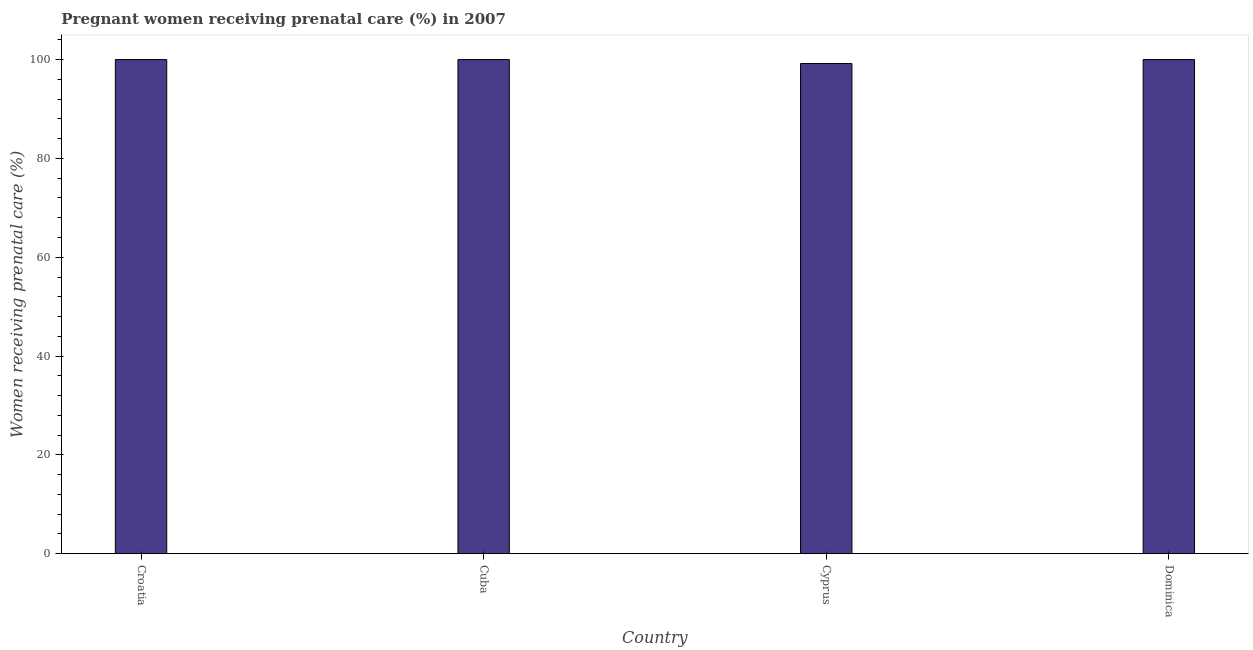Does the graph contain any zero values?
Offer a very short reply. No. What is the title of the graph?
Provide a succinct answer. Pregnant women receiving prenatal care (%) in 2007. What is the label or title of the Y-axis?
Offer a very short reply. Women receiving prenatal care (%). What is the percentage of pregnant women receiving prenatal care in Cyprus?
Your answer should be compact. 99.2. Across all countries, what is the minimum percentage of pregnant women receiving prenatal care?
Make the answer very short. 99.2. In which country was the percentage of pregnant women receiving prenatal care maximum?
Provide a short and direct response. Croatia. In which country was the percentage of pregnant women receiving prenatal care minimum?
Give a very brief answer. Cyprus. What is the sum of the percentage of pregnant women receiving prenatal care?
Your response must be concise. 399.2. What is the average percentage of pregnant women receiving prenatal care per country?
Provide a succinct answer. 99.8. What is the median percentage of pregnant women receiving prenatal care?
Offer a terse response. 100. Is the sum of the percentage of pregnant women receiving prenatal care in Cuba and Dominica greater than the maximum percentage of pregnant women receiving prenatal care across all countries?
Keep it short and to the point. Yes. What is the difference between the highest and the lowest percentage of pregnant women receiving prenatal care?
Offer a very short reply. 0.8. In how many countries, is the percentage of pregnant women receiving prenatal care greater than the average percentage of pregnant women receiving prenatal care taken over all countries?
Ensure brevity in your answer.  3. How many bars are there?
Provide a succinct answer. 4. Are all the bars in the graph horizontal?
Give a very brief answer. No. How many countries are there in the graph?
Make the answer very short. 4. Are the values on the major ticks of Y-axis written in scientific E-notation?
Your answer should be compact. No. What is the Women receiving prenatal care (%) of Croatia?
Provide a short and direct response. 100. What is the Women receiving prenatal care (%) of Cuba?
Provide a succinct answer. 100. What is the Women receiving prenatal care (%) of Cyprus?
Make the answer very short. 99.2. What is the Women receiving prenatal care (%) in Dominica?
Give a very brief answer. 100. What is the difference between the Women receiving prenatal care (%) in Croatia and Cuba?
Keep it short and to the point. 0. What is the difference between the Women receiving prenatal care (%) in Croatia and Cyprus?
Offer a very short reply. 0.8. What is the difference between the Women receiving prenatal care (%) in Croatia and Dominica?
Keep it short and to the point. 0. What is the difference between the Women receiving prenatal care (%) in Cuba and Cyprus?
Offer a very short reply. 0.8. What is the difference between the Women receiving prenatal care (%) in Cuba and Dominica?
Make the answer very short. 0. What is the difference between the Women receiving prenatal care (%) in Cyprus and Dominica?
Your answer should be very brief. -0.8. What is the ratio of the Women receiving prenatal care (%) in Croatia to that in Cuba?
Offer a terse response. 1. What is the ratio of the Women receiving prenatal care (%) in Croatia to that in Dominica?
Your answer should be compact. 1. What is the ratio of the Women receiving prenatal care (%) in Cuba to that in Cyprus?
Your answer should be compact. 1.01. What is the ratio of the Women receiving prenatal care (%) in Cuba to that in Dominica?
Your answer should be compact. 1. 